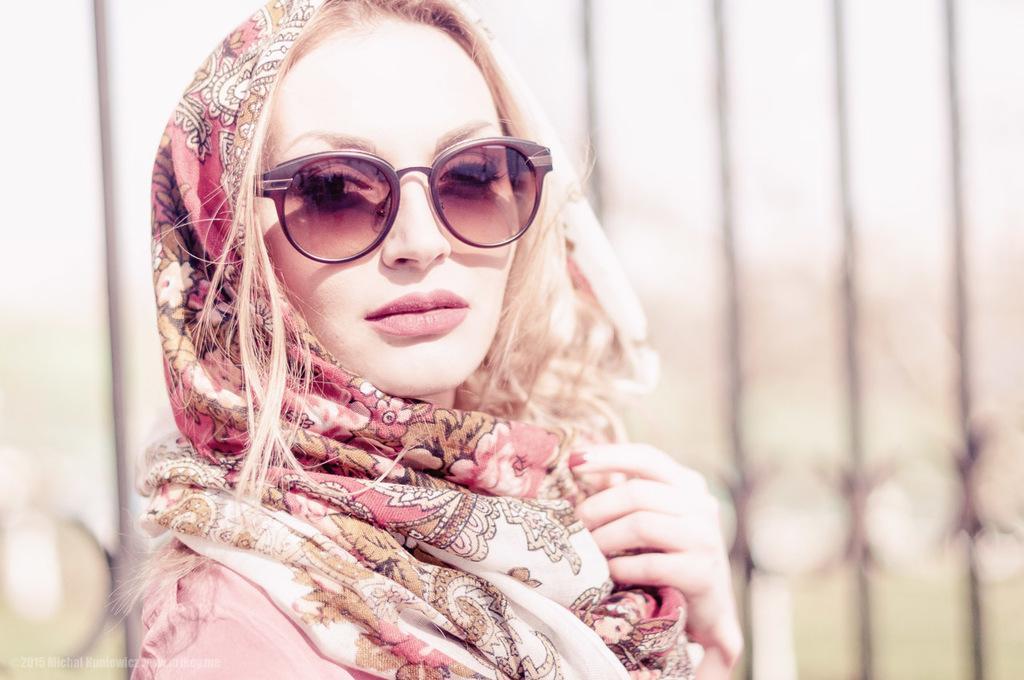How would you summarize this image in a sentence or two? In the center of the image there is a woman wearing spectacles. In the background we can see fencing. 